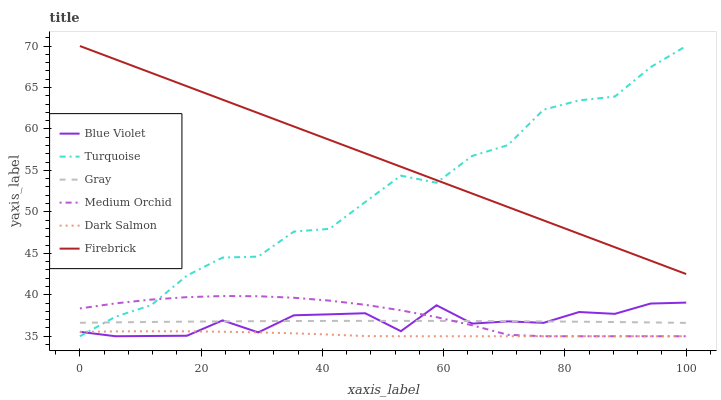Does Dark Salmon have the minimum area under the curve?
Answer yes or no. Yes. Does Firebrick have the maximum area under the curve?
Answer yes or no. Yes. Does Turquoise have the minimum area under the curve?
Answer yes or no. No. Does Turquoise have the maximum area under the curve?
Answer yes or no. No. Is Firebrick the smoothest?
Answer yes or no. Yes. Is Turquoise the roughest?
Answer yes or no. Yes. Is Turquoise the smoothest?
Answer yes or no. No. Is Firebrick the roughest?
Answer yes or no. No. Does Firebrick have the lowest value?
Answer yes or no. No. Does Firebrick have the highest value?
Answer yes or no. Yes. Does Medium Orchid have the highest value?
Answer yes or no. No. Is Blue Violet less than Firebrick?
Answer yes or no. Yes. Is Firebrick greater than Dark Salmon?
Answer yes or no. Yes. Does Medium Orchid intersect Gray?
Answer yes or no. Yes. Is Medium Orchid less than Gray?
Answer yes or no. No. Is Medium Orchid greater than Gray?
Answer yes or no. No. Does Blue Violet intersect Firebrick?
Answer yes or no. No. 